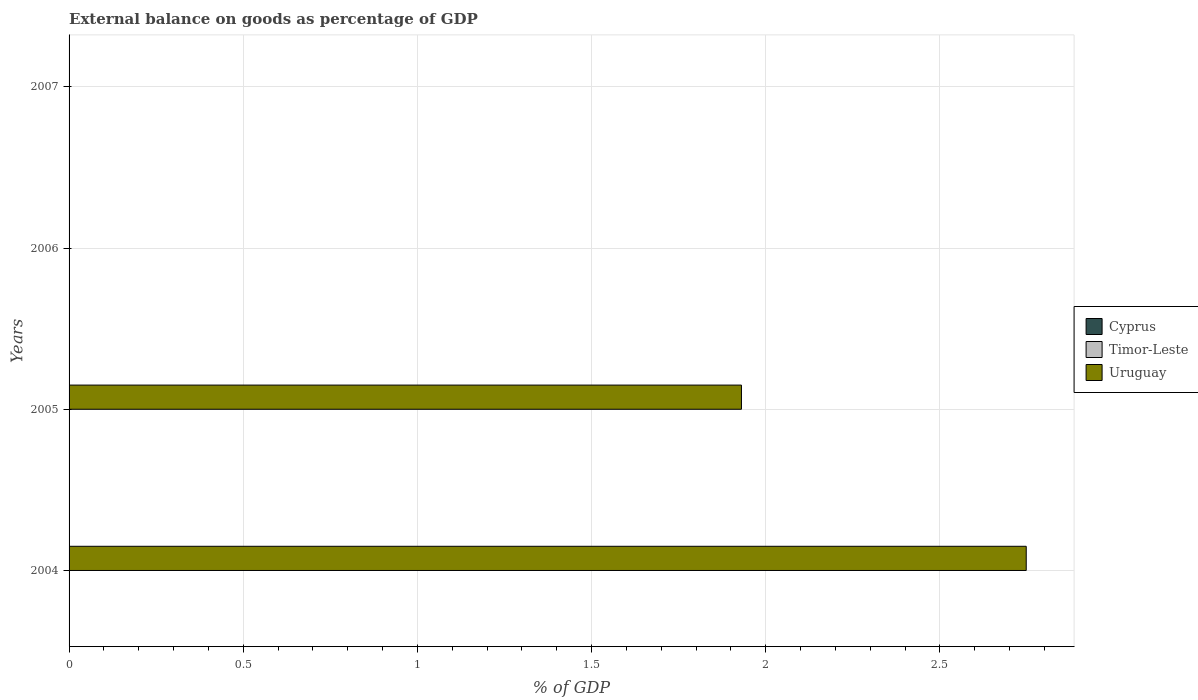How many different coloured bars are there?
Your response must be concise. 1. Are the number of bars on each tick of the Y-axis equal?
Offer a terse response. No. How many bars are there on the 3rd tick from the top?
Provide a short and direct response. 1. What is the label of the 1st group of bars from the top?
Offer a very short reply. 2007. In how many cases, is the number of bars for a given year not equal to the number of legend labels?
Make the answer very short. 4. Across all years, what is the maximum external balance on goods as percentage of GDP in Uruguay?
Your answer should be very brief. 2.75. Across all years, what is the minimum external balance on goods as percentage of GDP in Timor-Leste?
Your answer should be very brief. 0. What is the total external balance on goods as percentage of GDP in Uruguay in the graph?
Your response must be concise. 4.68. What is the difference between the external balance on goods as percentage of GDP in Timor-Leste in 2004 and the external balance on goods as percentage of GDP in Uruguay in 2005?
Ensure brevity in your answer.  -1.93. What is the average external balance on goods as percentage of GDP in Cyprus per year?
Provide a short and direct response. 0. In how many years, is the external balance on goods as percentage of GDP in Uruguay greater than 0.2 %?
Your response must be concise. 2. What is the ratio of the external balance on goods as percentage of GDP in Uruguay in 2004 to that in 2005?
Give a very brief answer. 1.42. Is the external balance on goods as percentage of GDP in Uruguay in 2004 less than that in 2005?
Ensure brevity in your answer.  No. What is the difference between the highest and the lowest external balance on goods as percentage of GDP in Uruguay?
Your answer should be compact. 2.75. In how many years, is the external balance on goods as percentage of GDP in Uruguay greater than the average external balance on goods as percentage of GDP in Uruguay taken over all years?
Provide a succinct answer. 2. Is it the case that in every year, the sum of the external balance on goods as percentage of GDP in Cyprus and external balance on goods as percentage of GDP in Uruguay is greater than the external balance on goods as percentage of GDP in Timor-Leste?
Your response must be concise. No. How many bars are there?
Provide a succinct answer. 2. Are all the bars in the graph horizontal?
Offer a terse response. Yes. How many years are there in the graph?
Make the answer very short. 4. What is the difference between two consecutive major ticks on the X-axis?
Make the answer very short. 0.5. Are the values on the major ticks of X-axis written in scientific E-notation?
Your answer should be compact. No. Does the graph contain any zero values?
Offer a very short reply. Yes. How are the legend labels stacked?
Offer a terse response. Vertical. What is the title of the graph?
Give a very brief answer. External balance on goods as percentage of GDP. Does "Barbados" appear as one of the legend labels in the graph?
Give a very brief answer. No. What is the label or title of the X-axis?
Provide a short and direct response. % of GDP. What is the label or title of the Y-axis?
Provide a short and direct response. Years. What is the % of GDP of Cyprus in 2004?
Make the answer very short. 0. What is the % of GDP in Uruguay in 2004?
Your answer should be compact. 2.75. What is the % of GDP of Cyprus in 2005?
Provide a succinct answer. 0. What is the % of GDP in Timor-Leste in 2005?
Offer a very short reply. 0. What is the % of GDP of Uruguay in 2005?
Offer a terse response. 1.93. What is the % of GDP in Uruguay in 2006?
Provide a succinct answer. 0. What is the % of GDP of Timor-Leste in 2007?
Give a very brief answer. 0. Across all years, what is the maximum % of GDP of Uruguay?
Make the answer very short. 2.75. What is the total % of GDP of Uruguay in the graph?
Offer a terse response. 4.68. What is the difference between the % of GDP in Uruguay in 2004 and that in 2005?
Keep it short and to the point. 0.82. What is the average % of GDP in Uruguay per year?
Offer a terse response. 1.17. What is the ratio of the % of GDP in Uruguay in 2004 to that in 2005?
Offer a terse response. 1.42. What is the difference between the highest and the lowest % of GDP of Uruguay?
Offer a very short reply. 2.75. 